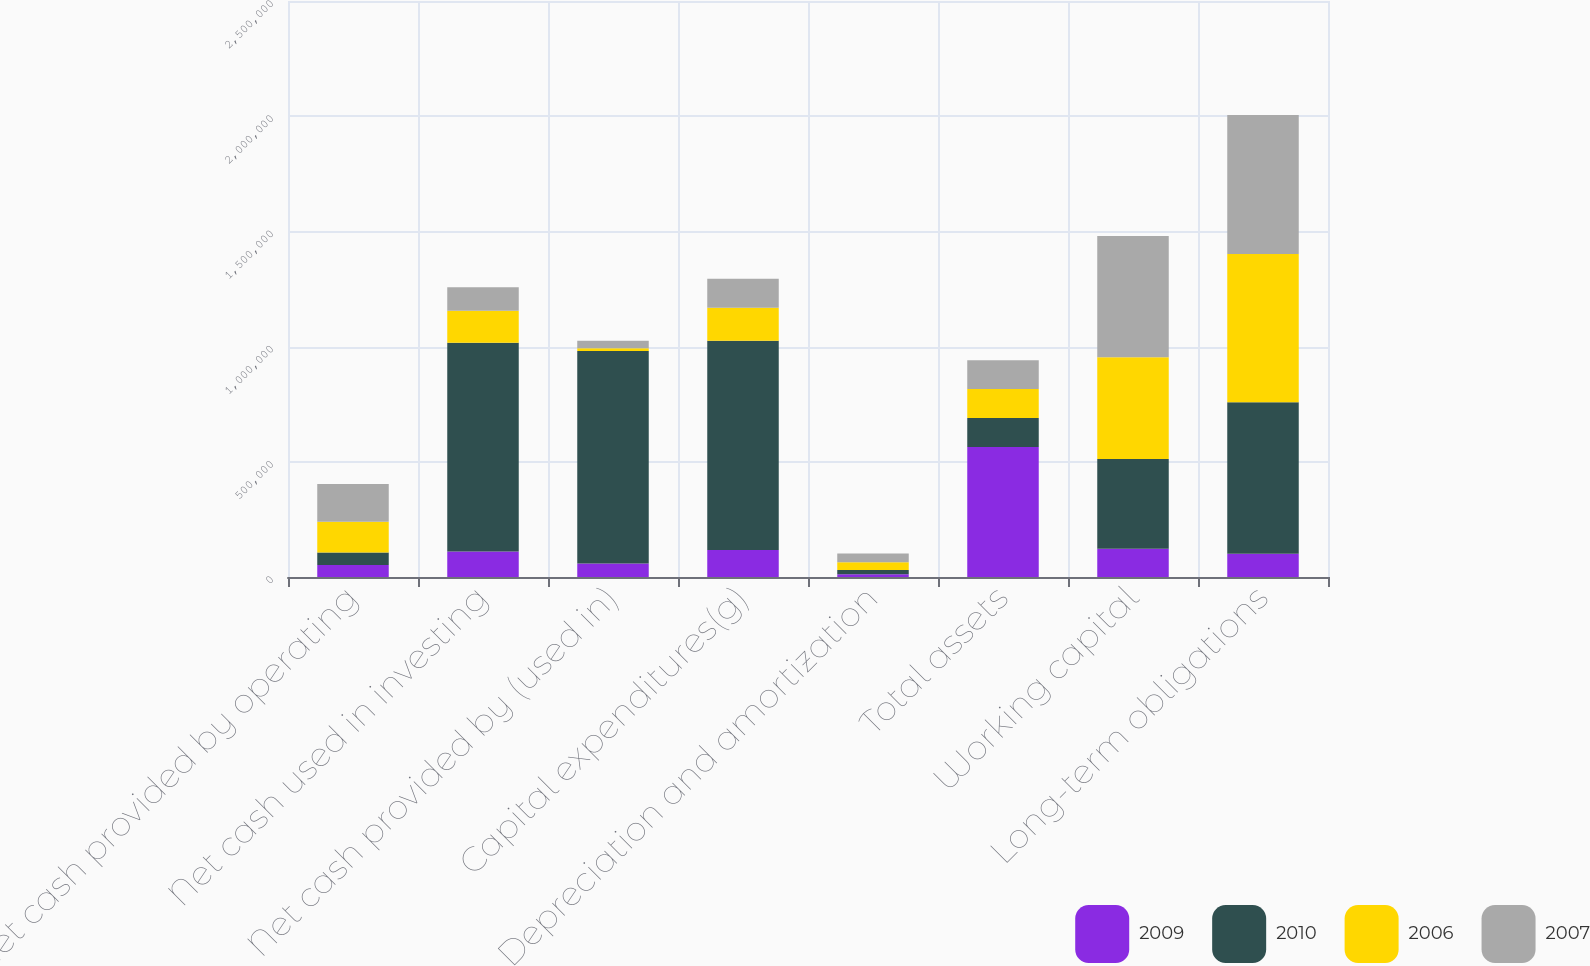Convert chart to OTSL. <chart><loc_0><loc_0><loc_500><loc_500><stacked_bar_chart><ecel><fcel>Net cash provided by operating<fcel>Net cash used in investing<fcel>Net cash provided by (used in)<fcel>Capital expenditures(g)<fcel>Depreciation and amortization<fcel>Total assets<fcel>Working capital<fcel>Long-term obligations<nl><fcel>2009<fcel>52381<fcel>110657<fcel>59134<fcel>116844<fcel>12086<fcel>564355<fcel>122420<fcel>100447<nl><fcel>2010<fcel>54369<fcel>905821<fcel>921629<fcel>908122<fcel>18018<fcel>125624<fcel>389469<fcel>658462<nl><fcel>2006<fcel>132961<fcel>138910<fcel>11793<fcel>143435<fcel>33421<fcel>125624<fcel>441705<fcel>642874<nl><fcel>2007<fcel>164002<fcel>102494<fcel>33165<fcel>125624<fcel>38062<fcel>125624<fcel>526125<fcel>603045<nl></chart> 